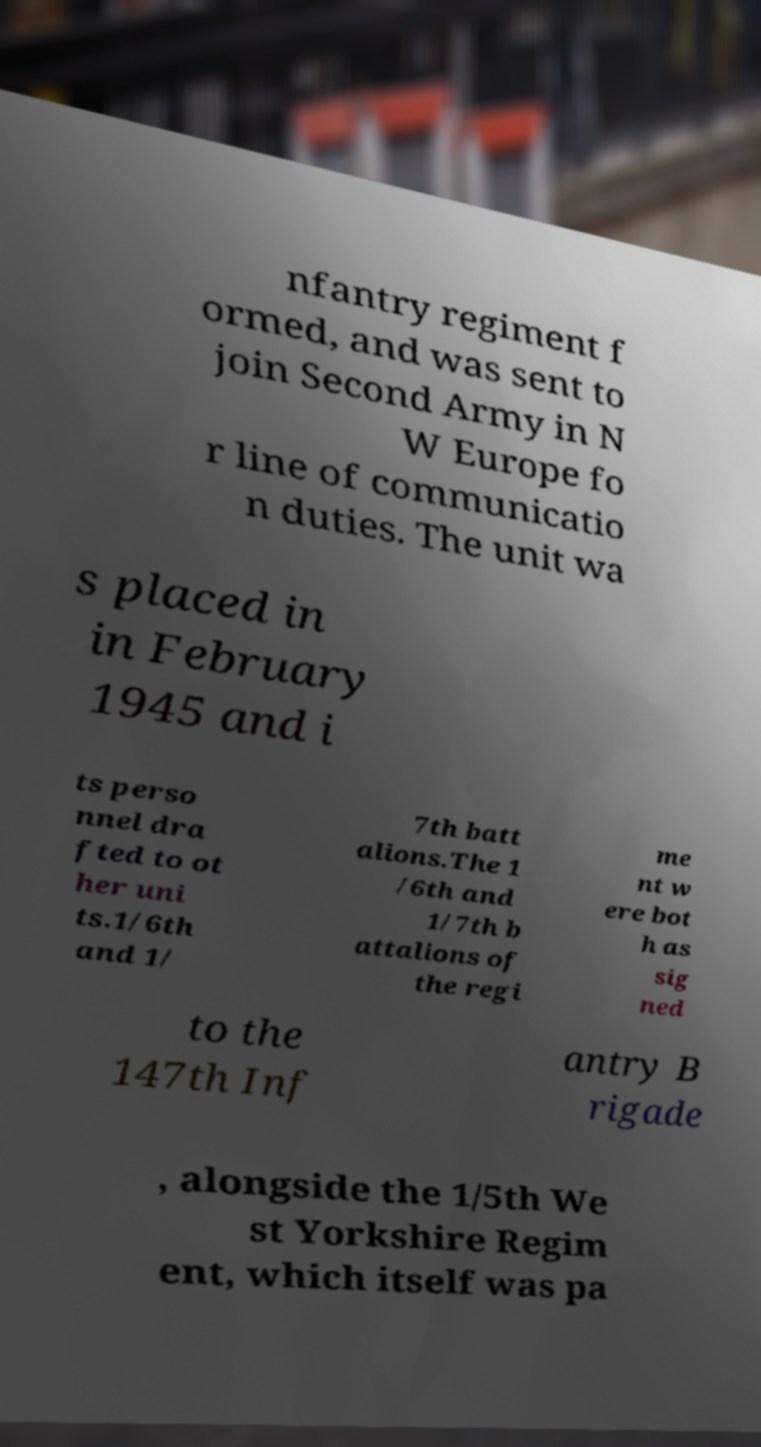I need the written content from this picture converted into text. Can you do that? nfantry regiment f ormed, and was sent to join Second Army in N W Europe fo r line of communicatio n duties. The unit wa s placed in in February 1945 and i ts perso nnel dra fted to ot her uni ts.1/6th and 1/ 7th batt alions.The 1 /6th and 1/7th b attalions of the regi me nt w ere bot h as sig ned to the 147th Inf antry B rigade , alongside the 1/5th We st Yorkshire Regim ent, which itself was pa 